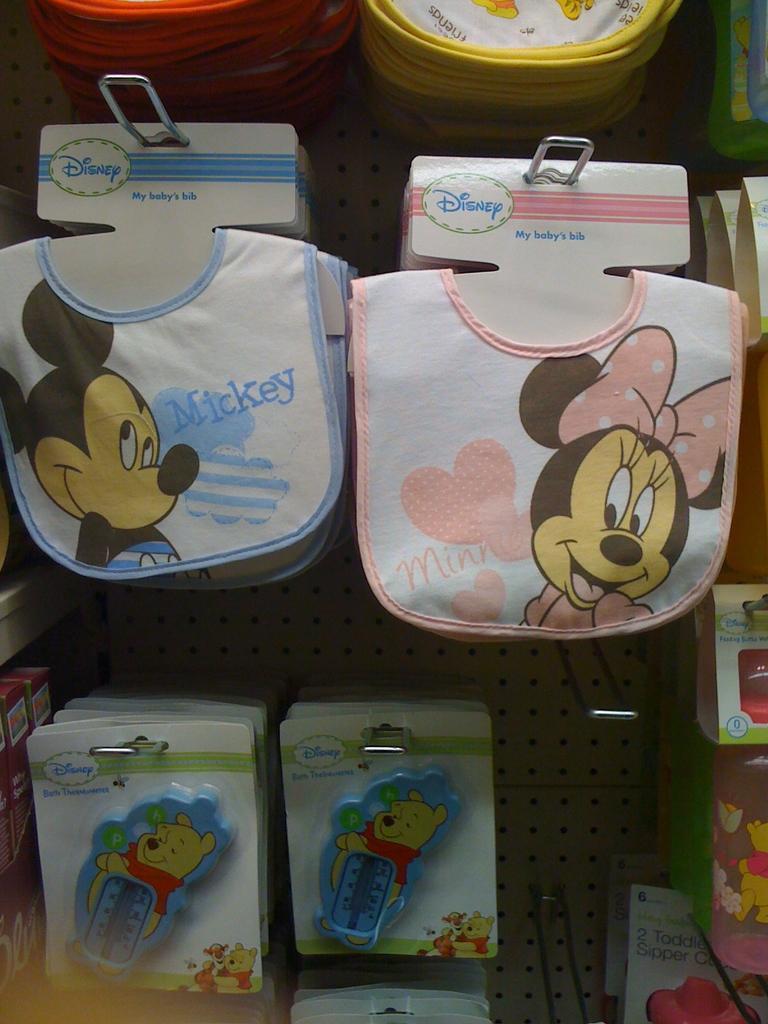Could you give a brief overview of what you see in this image? In this image there are a few baby napkins and there are a few toys on the board. 